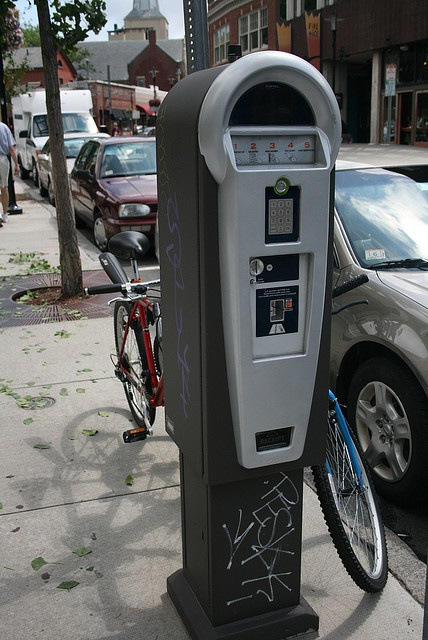Describe the objects in this image and their specific colors. I can see parking meter in black and gray tones, car in black, gray, lightgray, and darkgray tones, bicycle in black, gray, darkgray, and blue tones, bicycle in black, gray, darkgray, and maroon tones, and car in black, gray, and darkgray tones in this image. 